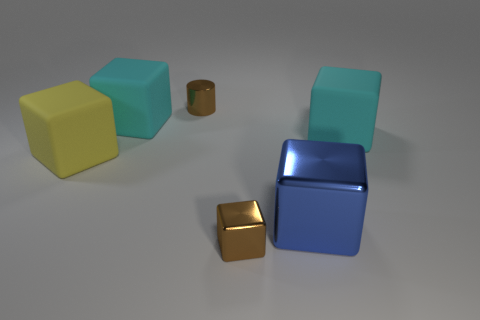Subtract all big metal cubes. How many cubes are left? 4 Subtract all blue cylinders. How many cyan cubes are left? 2 Subtract all cyan cubes. How many cubes are left? 3 Add 1 cylinders. How many objects exist? 7 Subtract all blocks. How many objects are left? 1 Subtract 2 cubes. How many cubes are left? 3 Subtract all gray blocks. Subtract all purple balls. How many blocks are left? 5 Add 2 blue cubes. How many blue cubes exist? 3 Subtract 0 red cubes. How many objects are left? 6 Subtract all green shiny blocks. Subtract all brown cylinders. How many objects are left? 5 